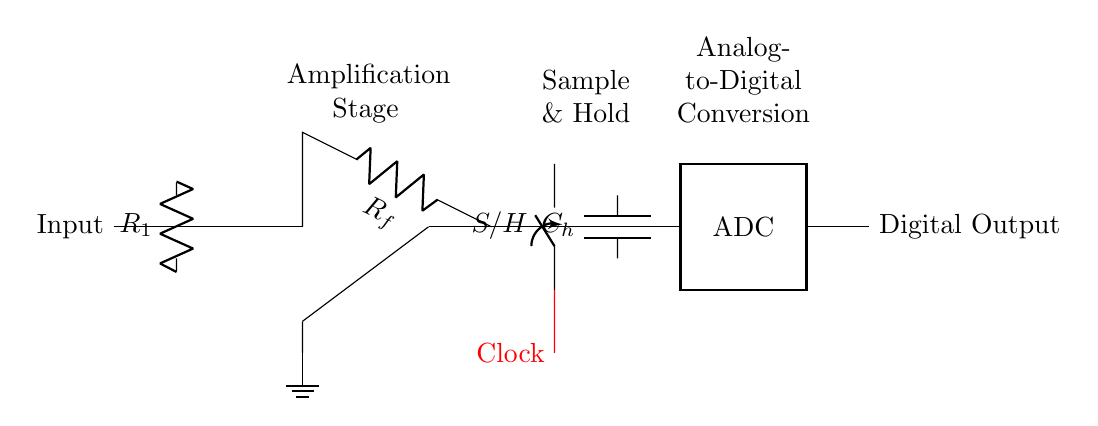What is the role of the operational amplifier? The operational amplifier is used to amplify the input signal, which boosts the voltage before it is processed further in the circuit.
Answer: Amplification What component is directly associated with the sample-and-hold function? The sample-and-hold function is specifically performed by the switch labeled S/H, which captures the analog voltage and holds it for conversion.
Answer: Switch How many resistors are present in the circuit? There are two resistors, R1 and Rf, which are part of the amplification and feedback network.
Answer: Two What is the purpose of the capacitor labeled C_h? The capacitor C_h stores the voltage sampled by the circuit during the hold phase, maintaining the voltage level for the ADC processing.
Answer: Voltage storage What signals the sample-and-hold circuit to sample the voltage? The clock signal, represented in red, signals the sample-and-hold circuit when to sample the incoming analog voltage.
Answer: Clock signal What type of conversion does the ADC perform? The ADC converts the analog voltage held by the capacitor into a digital output that can be processed by digital systems.
Answer: Analog-to-digital conversion 